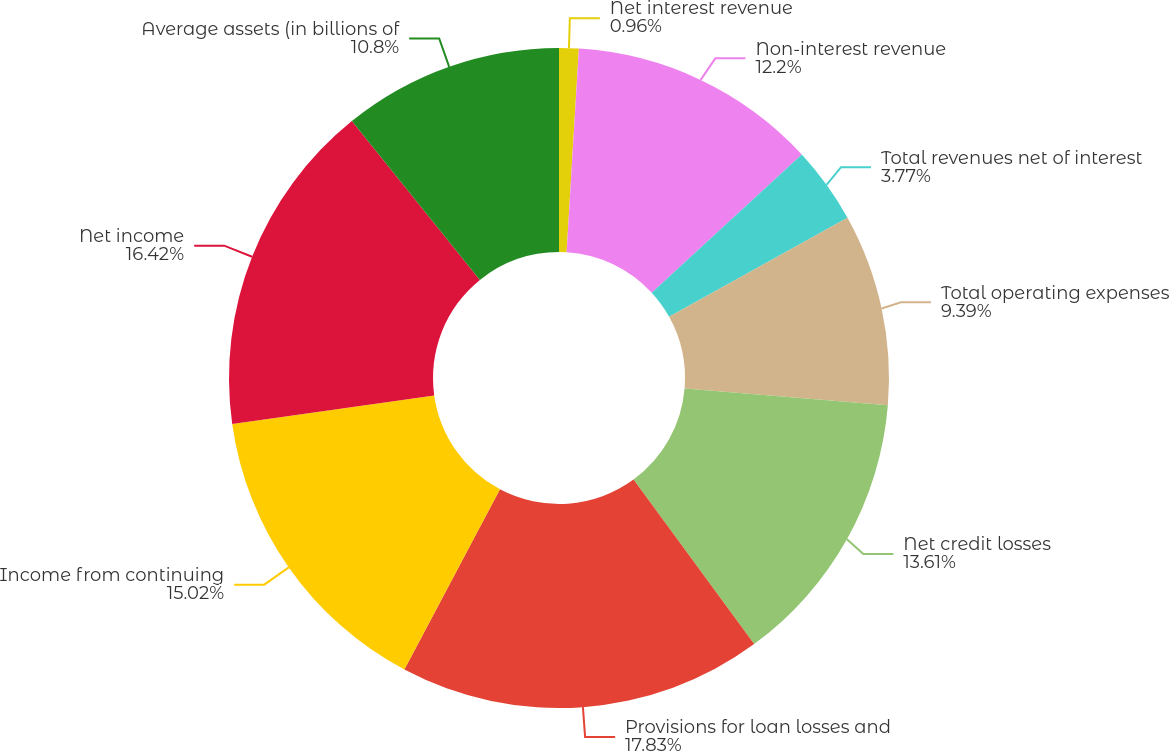Convert chart to OTSL. <chart><loc_0><loc_0><loc_500><loc_500><pie_chart><fcel>Net interest revenue<fcel>Non-interest revenue<fcel>Total revenues net of interest<fcel>Total operating expenses<fcel>Net credit losses<fcel>Provisions for loan losses and<fcel>Income from continuing<fcel>Net income<fcel>Average assets (in billions of<nl><fcel>0.96%<fcel>12.2%<fcel>3.77%<fcel>9.39%<fcel>13.61%<fcel>17.83%<fcel>15.02%<fcel>16.42%<fcel>10.8%<nl></chart> 